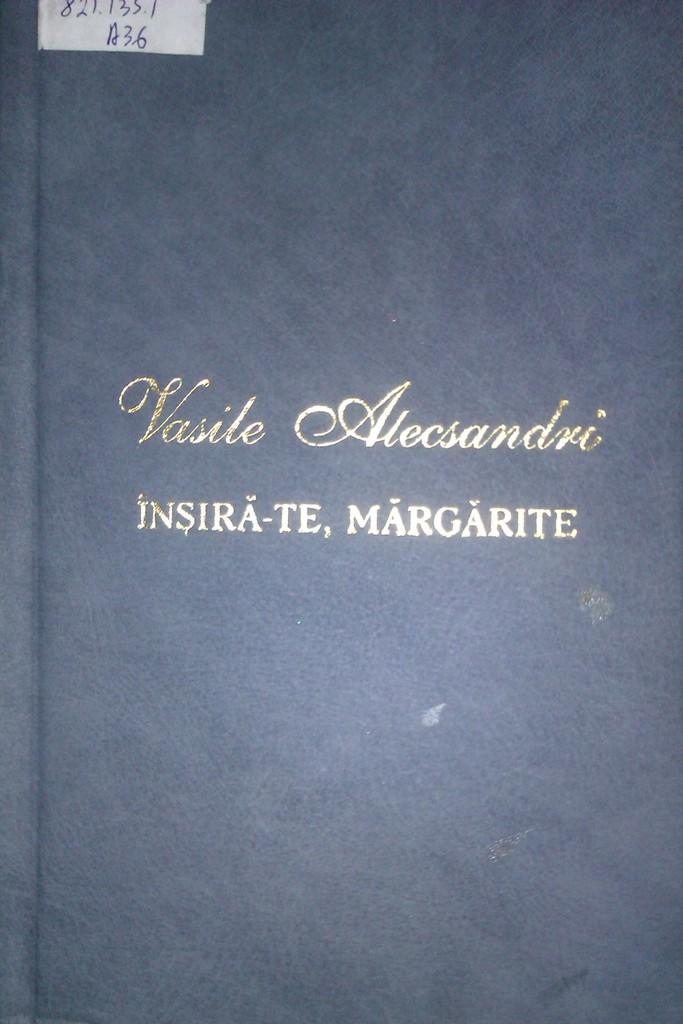Who is the author of the book?
Ensure brevity in your answer.  Vasile alecsandri. What is the title?
Offer a very short reply. Vasile alecsandri. 